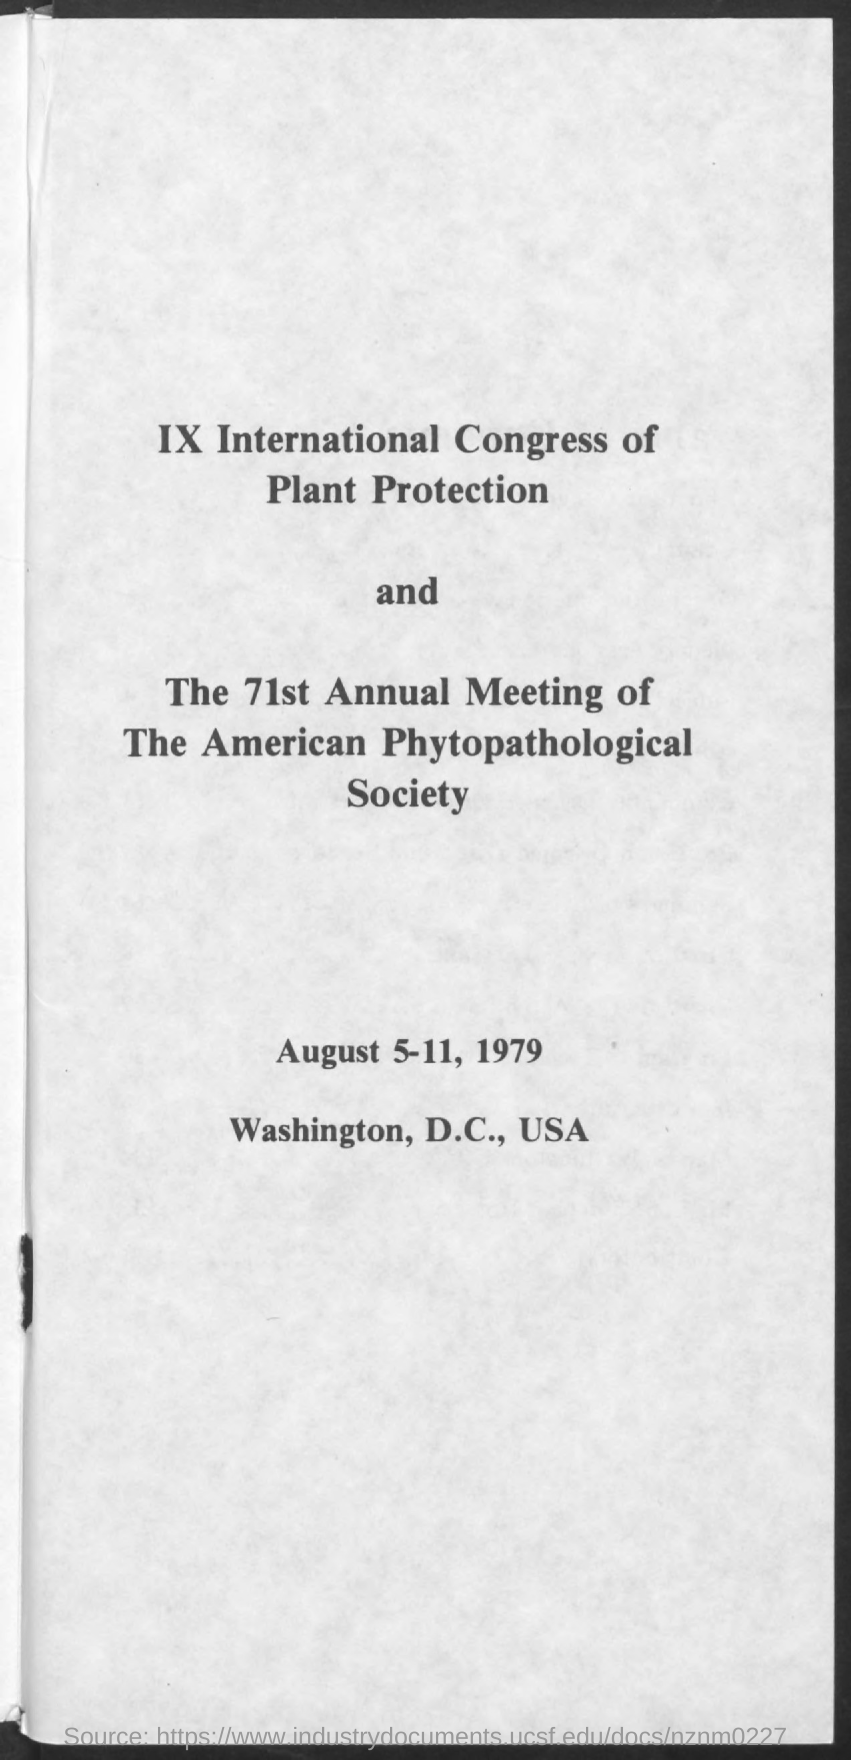What is the date mentioned in the given page ?
Give a very brief answer. August 5-11 , 1979. 